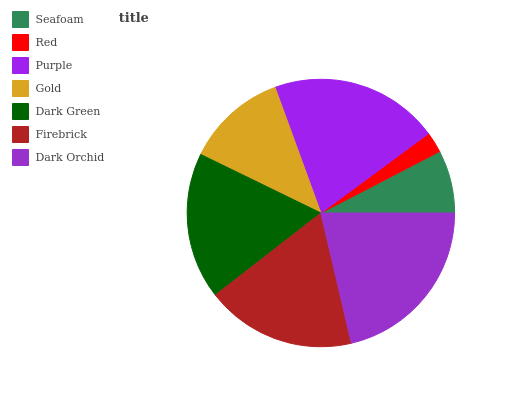Is Red the minimum?
Answer yes or no. Yes. Is Dark Orchid the maximum?
Answer yes or no. Yes. Is Purple the minimum?
Answer yes or no. No. Is Purple the maximum?
Answer yes or no. No. Is Purple greater than Red?
Answer yes or no. Yes. Is Red less than Purple?
Answer yes or no. Yes. Is Red greater than Purple?
Answer yes or no. No. Is Purple less than Red?
Answer yes or no. No. Is Dark Green the high median?
Answer yes or no. Yes. Is Dark Green the low median?
Answer yes or no. Yes. Is Firebrick the high median?
Answer yes or no. No. Is Dark Orchid the low median?
Answer yes or no. No. 